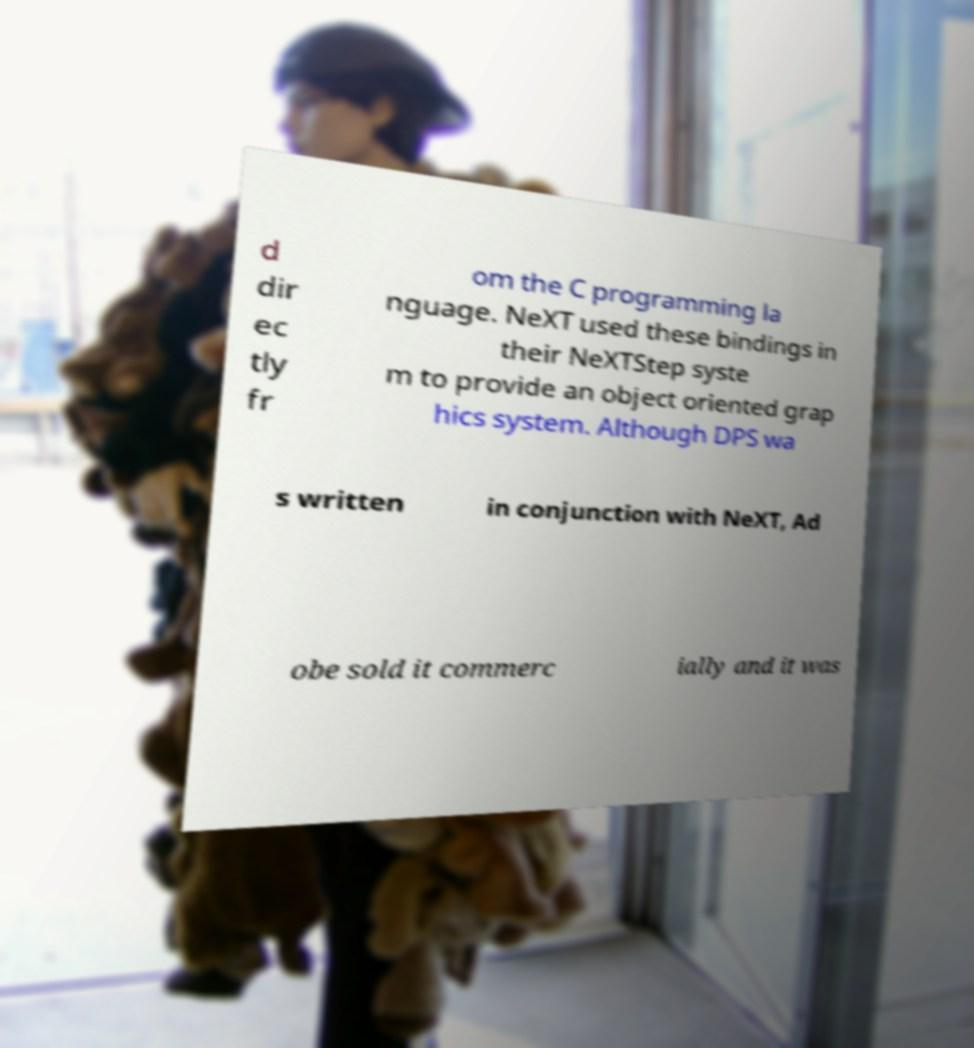Could you assist in decoding the text presented in this image and type it out clearly? d dir ec tly fr om the C programming la nguage. NeXT used these bindings in their NeXTStep syste m to provide an object oriented grap hics system. Although DPS wa s written in conjunction with NeXT, Ad obe sold it commerc ially and it was 